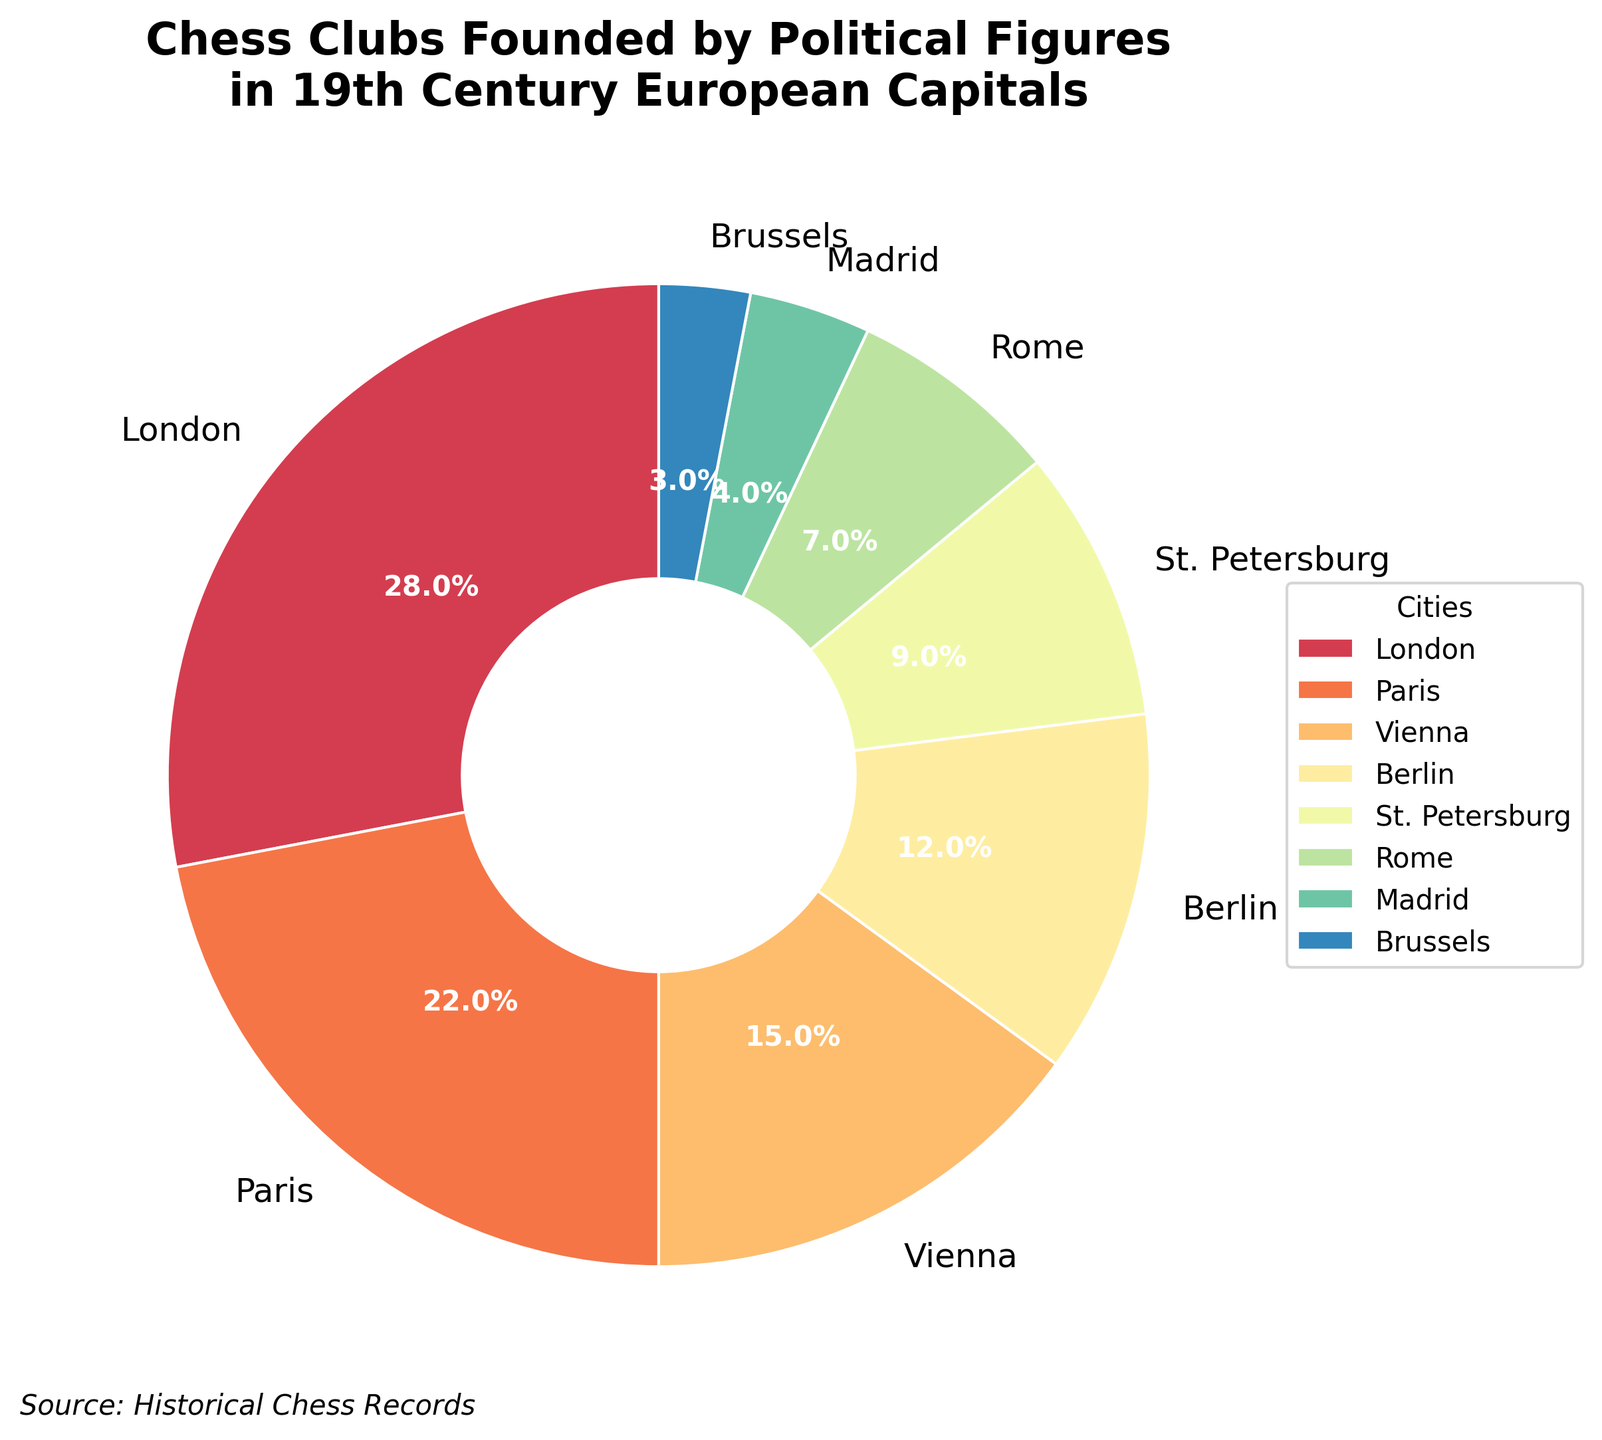Which city had the highest percentage of chess clubs founded by political figures in the 19th century? The pie chart shows the percentage for each city, with London having the largest slice at 28%.
Answer: London Which city had the smallest percentage of chess clubs founded by political figures in the 19th century? The pie chart shows the percentage for each city, with Brussels having the smallest slice at 3%.
Answer: Brussels How much greater is the percentage of chess clubs in London compared to St. Petersburg? London's percentage is 28% and St. Petersburg's percentage is 9%. The difference is 28% - 9% = 19%.
Answer: 19% What is the combined percentage of chess clubs founded by political figures in Paris and Vienna? Paris has 22% and Vienna has 15%. Combined, this is 22% + 15% = 37%.
Answer: 37% Which cities have a percentage of chess clubs founded by political figures that is greater than 10%? The cities with percentages greater than 10% are London (28%), Paris (22%), Vienna (15%), and Berlin (12%).
Answer: London, Paris, Vienna, Berlin What is the average percentage of chess clubs founded by political figures in the cities with the four smallest percentages? The cities with the smallest percentages are St. Petersburg (9%), Rome (7%), Madrid (4%), Brussels (3%). The sum is 9% + 7% + 4% + 3% = 23%. The average is 23% / 4 = 5.75%.
Answer: 5.75% Which city has a percentage of chess clubs founded by political figures closest to the average percentage? Summing all percentages gives 100%, and there are 8 cities, making the average 100% / 8 = 12.5%. Berlin, with 12%, is closest to this average.
Answer: Berlin How does the percentage of chess clubs in Rome compare to the combined percentage of chess clubs in Madrid and Brussels? Rome has 7%, while Madrid and Brussels combined have 4% + 3% = 7%. Therefore, they are equal.
Answer: They are equal What is the total percentage of chess clubs founded by political figures in cities other than London and Paris? Excluding London (28%) and Paris (22%), the total for the other cities is 100% - 28% - 22% = 50%.
Answer: 50% 